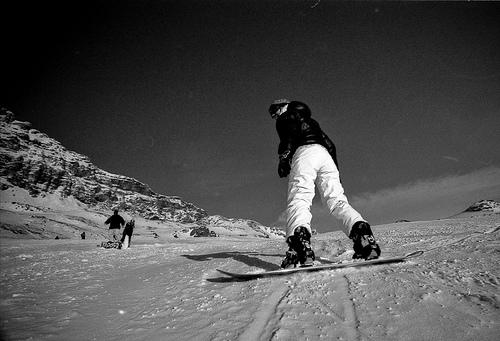Is this a black and white picture?
Give a very brief answer. Yes. Is the persons pants blue?
Answer briefly. No. Is this person skiing?
Give a very brief answer. No. Are they talking to each other?
Quick response, please. No. 